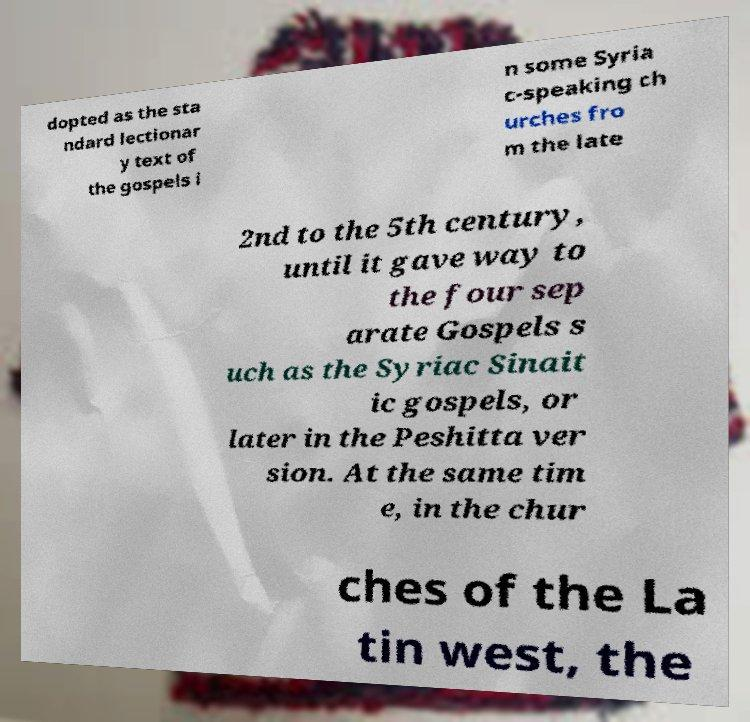Could you extract and type out the text from this image? dopted as the sta ndard lectionar y text of the gospels i n some Syria c-speaking ch urches fro m the late 2nd to the 5th century, until it gave way to the four sep arate Gospels s uch as the Syriac Sinait ic gospels, or later in the Peshitta ver sion. At the same tim e, in the chur ches of the La tin west, the 